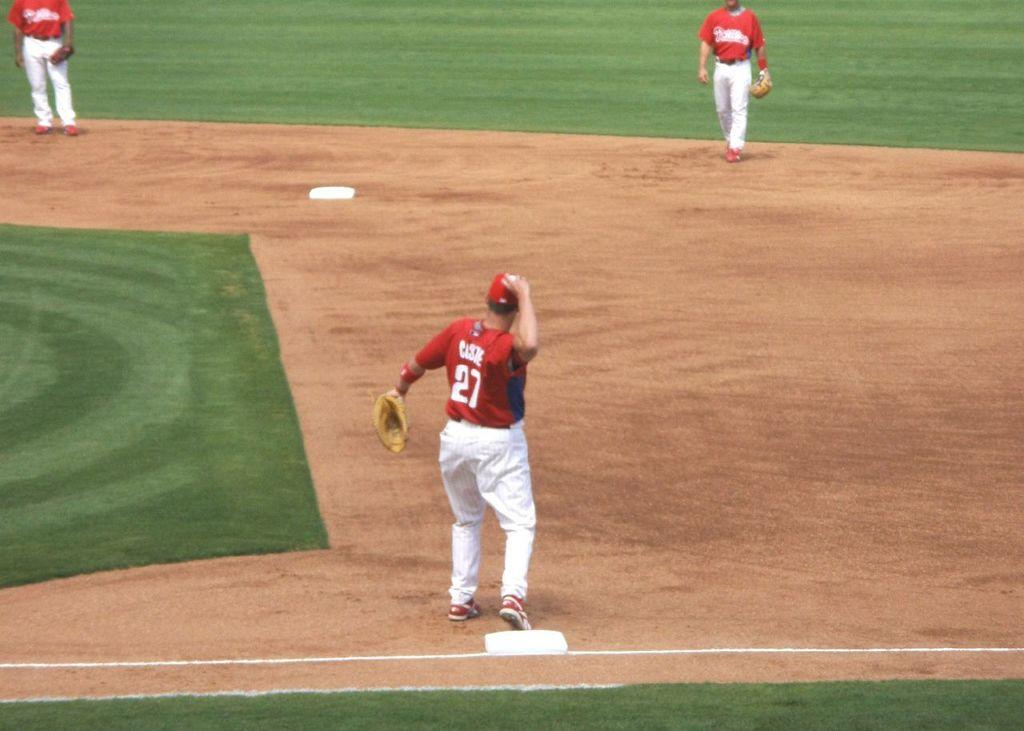Provide a one-sentence caption for the provided image. A man with number 27 on his jersey throwing a ball. 